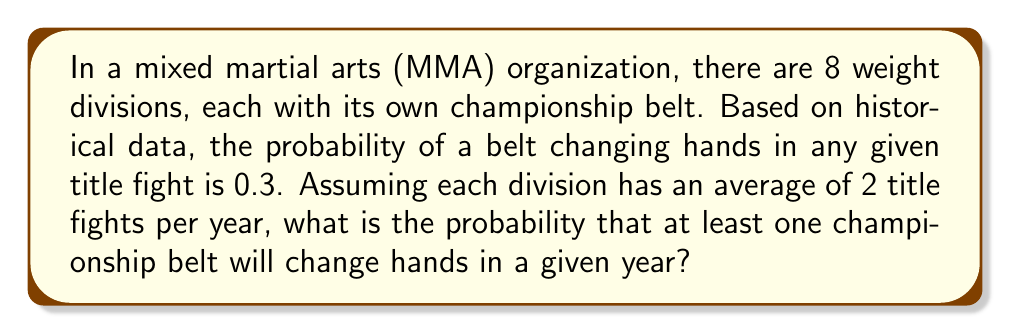What is the answer to this math problem? Let's approach this step-by-step:

1) First, let's consider the probability of a belt not changing hands in a single title fight:
   $P(\text{belt not changing}) = 1 - 0.3 = 0.7$

2) For each division, there are 2 title fights per year. The probability of the belt not changing hands in both fights is:
   $P(\text{no change in division}) = 0.7 \times 0.7 = 0.7^2 = 0.49$

3) Now, we need to calculate the probability of no belts changing hands in any of the 8 divisions. This is:
   $P(\text{no change in any division}) = 0.49^8$

4) Therefore, the probability of at least one belt changing hands is the complement of this:
   $P(\text{at least one change}) = 1 - P(\text{no change in any division})$
   $= 1 - 0.49^8$

5) Let's calculate this:
   $1 - 0.49^8 = 1 - 0.0000610656 = 0.9999389344$

This can be rounded to 0.99994 or expressed as about 99.994%.
Answer: The probability that at least one championship belt will change hands in a given year is approximately 0.99994 or 99.994%. 